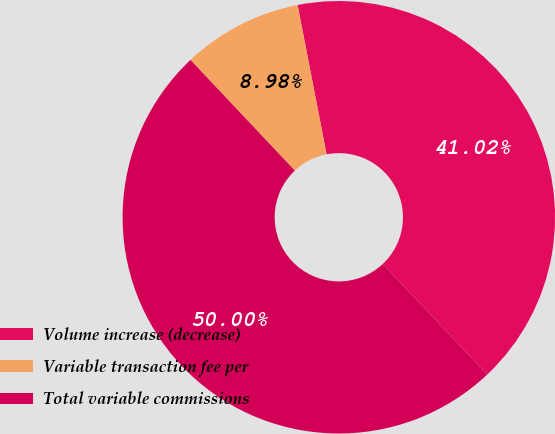Convert chart to OTSL. <chart><loc_0><loc_0><loc_500><loc_500><pie_chart><fcel>Volume increase (decrease)<fcel>Variable transaction fee per<fcel>Total variable commissions<nl><fcel>41.02%<fcel>8.98%<fcel>50.0%<nl></chart> 